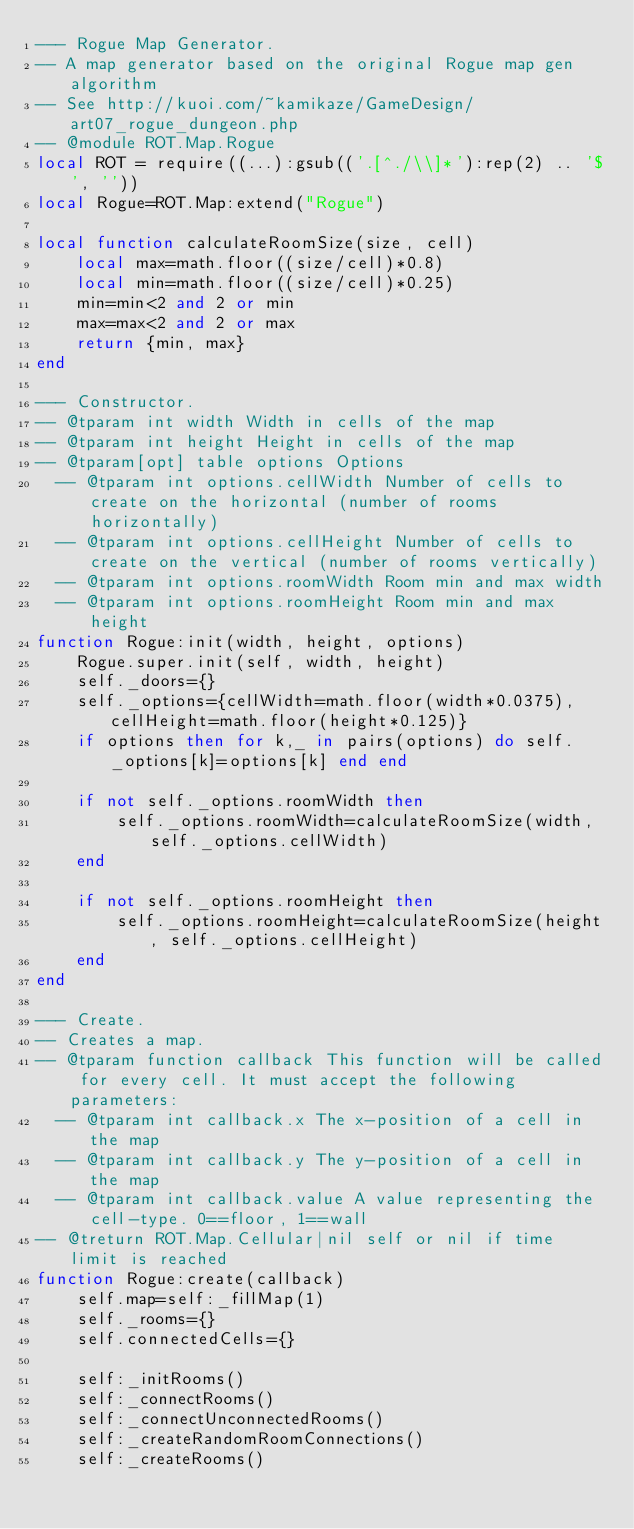<code> <loc_0><loc_0><loc_500><loc_500><_Lua_>--- Rogue Map Generator.
-- A map generator based on the original Rogue map gen algorithm
-- See http://kuoi.com/~kamikaze/GameDesign/art07_rogue_dungeon.php
-- @module ROT.Map.Rogue
local ROT = require((...):gsub(('.[^./\\]*'):rep(2) .. '$', ''))
local Rogue=ROT.Map:extend("Rogue")

local function calculateRoomSize(size, cell)
    local max=math.floor((size/cell)*0.8)
    local min=math.floor((size/cell)*0.25)
    min=min<2 and 2 or min
    max=max<2 and 2 or max
    return {min, max}
end

--- Constructor.
-- @tparam int width Width in cells of the map
-- @tparam int height Height in cells of the map
-- @tparam[opt] table options Options
  -- @tparam int options.cellWidth Number of cells to create on the horizontal (number of rooms horizontally)
  -- @tparam int options.cellHeight Number of cells to create on the vertical (number of rooms vertically)
  -- @tparam int options.roomWidth Room min and max width
  -- @tparam int options.roomHeight Room min and max height
function Rogue:init(width, height, options)
    Rogue.super.init(self, width, height)
    self._doors={}
    self._options={cellWidth=math.floor(width*0.0375), cellHeight=math.floor(height*0.125)}
    if options then for k,_ in pairs(options) do self._options[k]=options[k] end end

    if not self._options.roomWidth then
        self._options.roomWidth=calculateRoomSize(width, self._options.cellWidth)
    end

    if not self._options.roomHeight then
        self._options.roomHeight=calculateRoomSize(height, self._options.cellHeight)
    end
end

--- Create.
-- Creates a map.
-- @tparam function callback This function will be called for every cell. It must accept the following parameters:
  -- @tparam int callback.x The x-position of a cell in the map
  -- @tparam int callback.y The y-position of a cell in the map
  -- @tparam int callback.value A value representing the cell-type. 0==floor, 1==wall
-- @treturn ROT.Map.Cellular|nil self or nil if time limit is reached
function Rogue:create(callback)
    self.map=self:_fillMap(1)
    self._rooms={}
    self.connectedCells={}

    self:_initRooms()
    self:_connectRooms()
    self:_connectUnconnectedRooms()
    self:_createRandomRoomConnections()
    self:_createRooms()</code> 